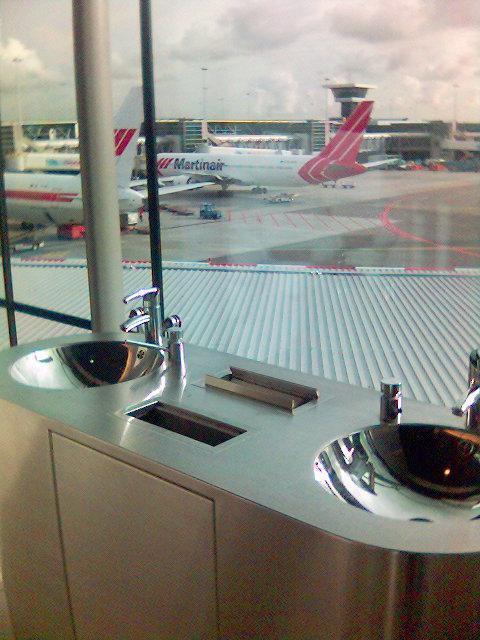How many sinks are visible?
Give a very brief answer. 2. How many airplanes are in the picture?
Give a very brief answer. 2. How many ski lift chairs are visible?
Give a very brief answer. 0. 